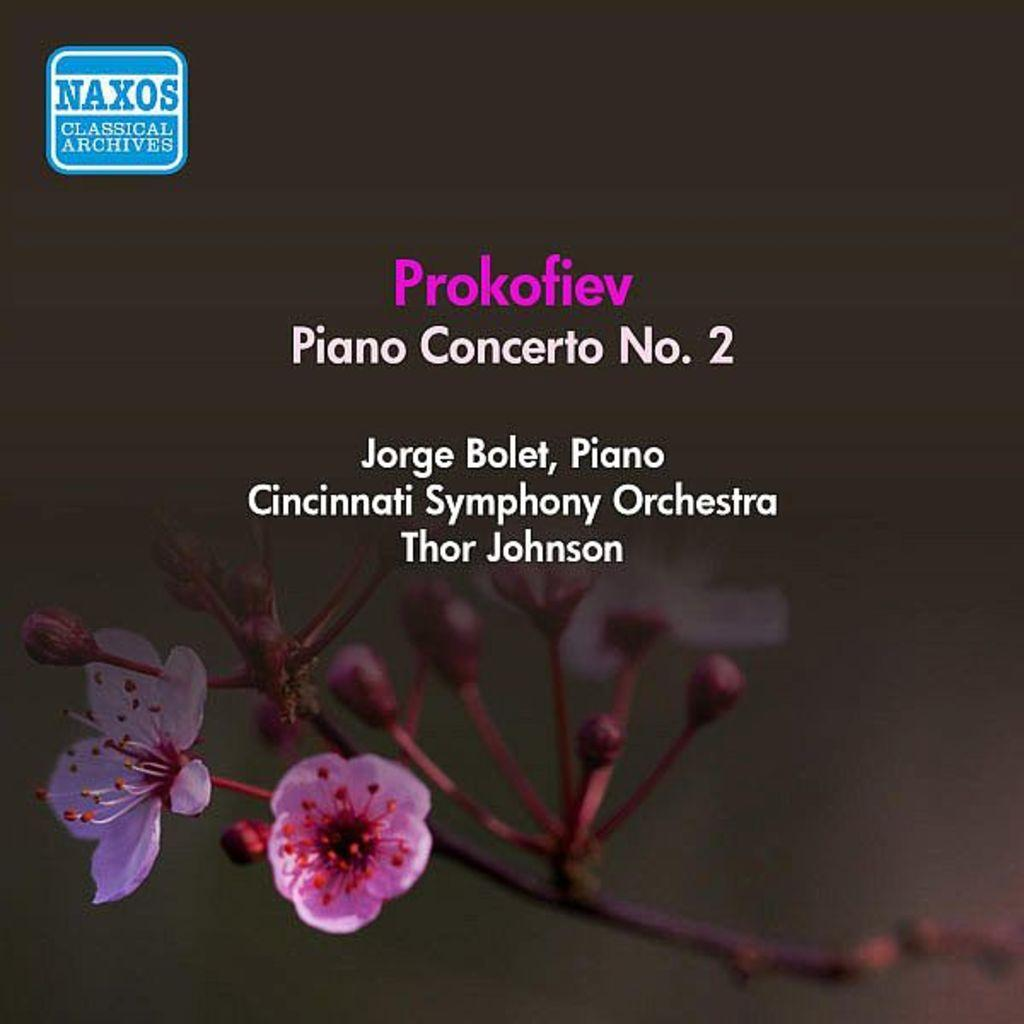<image>
Relay a brief, clear account of the picture shown. A cover for Piano Concerto No. 2 is shown with purple flowers below. 